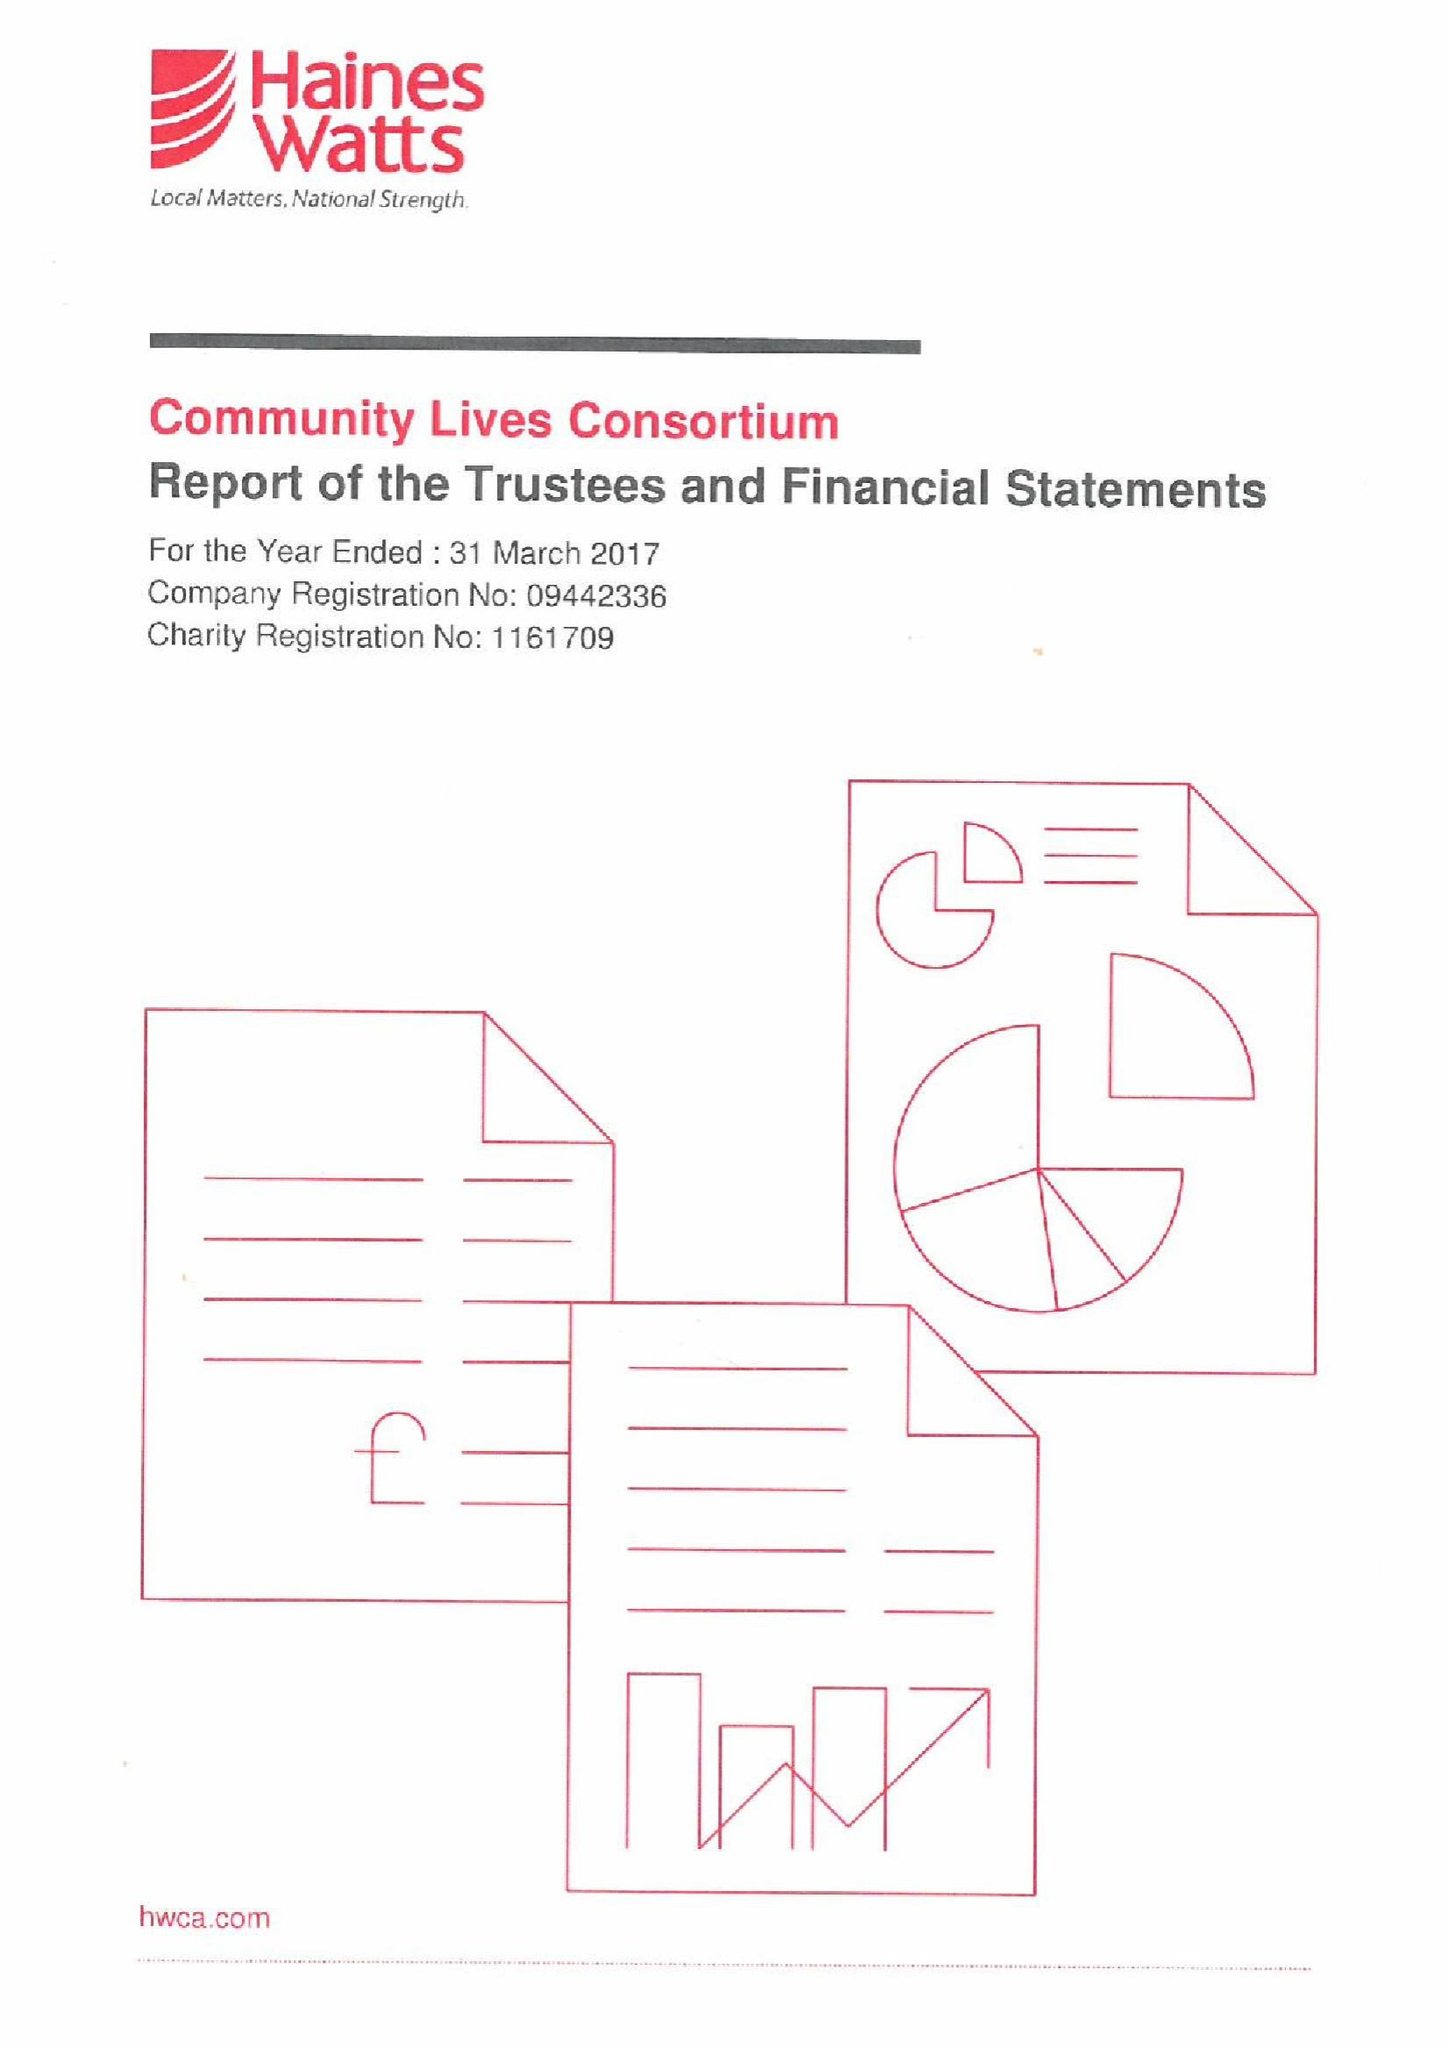What is the value for the charity_number?
Answer the question using a single word or phrase. 1161709 